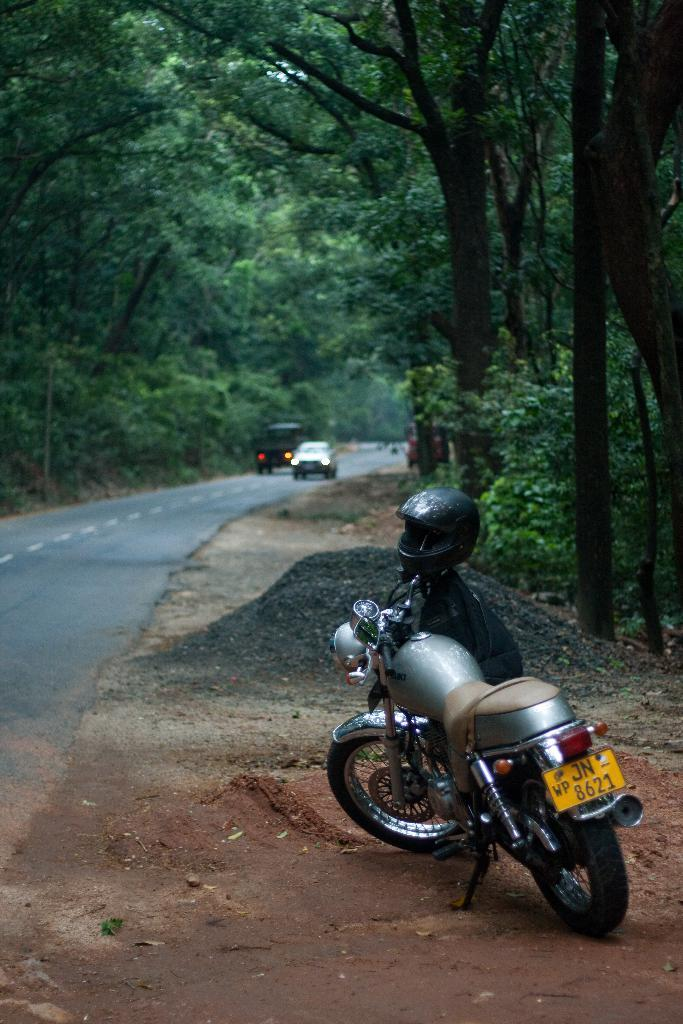What object can be seen in the image that might be used for carrying items? There is a bag in the image that might be used for carrying items. What safety equipment is visible in the image? A helmet is on a bike in the image. What types of transportation are visible in the image? There are vehicles visible in the image. What type of vegetation is present on the road in the image? Green trees are present on the road in the image. What type of account is being discussed in the image? There is no mention of an account in the image; it features a bag, a helmet on a bike, vehicles, and green trees on the road. 